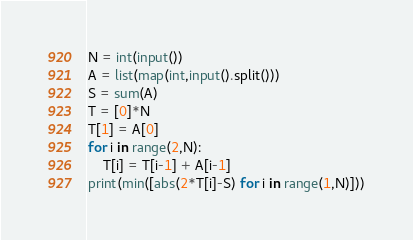<code> <loc_0><loc_0><loc_500><loc_500><_Python_>N = int(input())
A = list(map(int,input().split()))
S = sum(A)
T = [0]*N
T[1] = A[0]
for i in range(2,N):
    T[i] = T[i-1] + A[i-1]
print(min([abs(2*T[i]-S) for i in range(1,N)]))</code> 